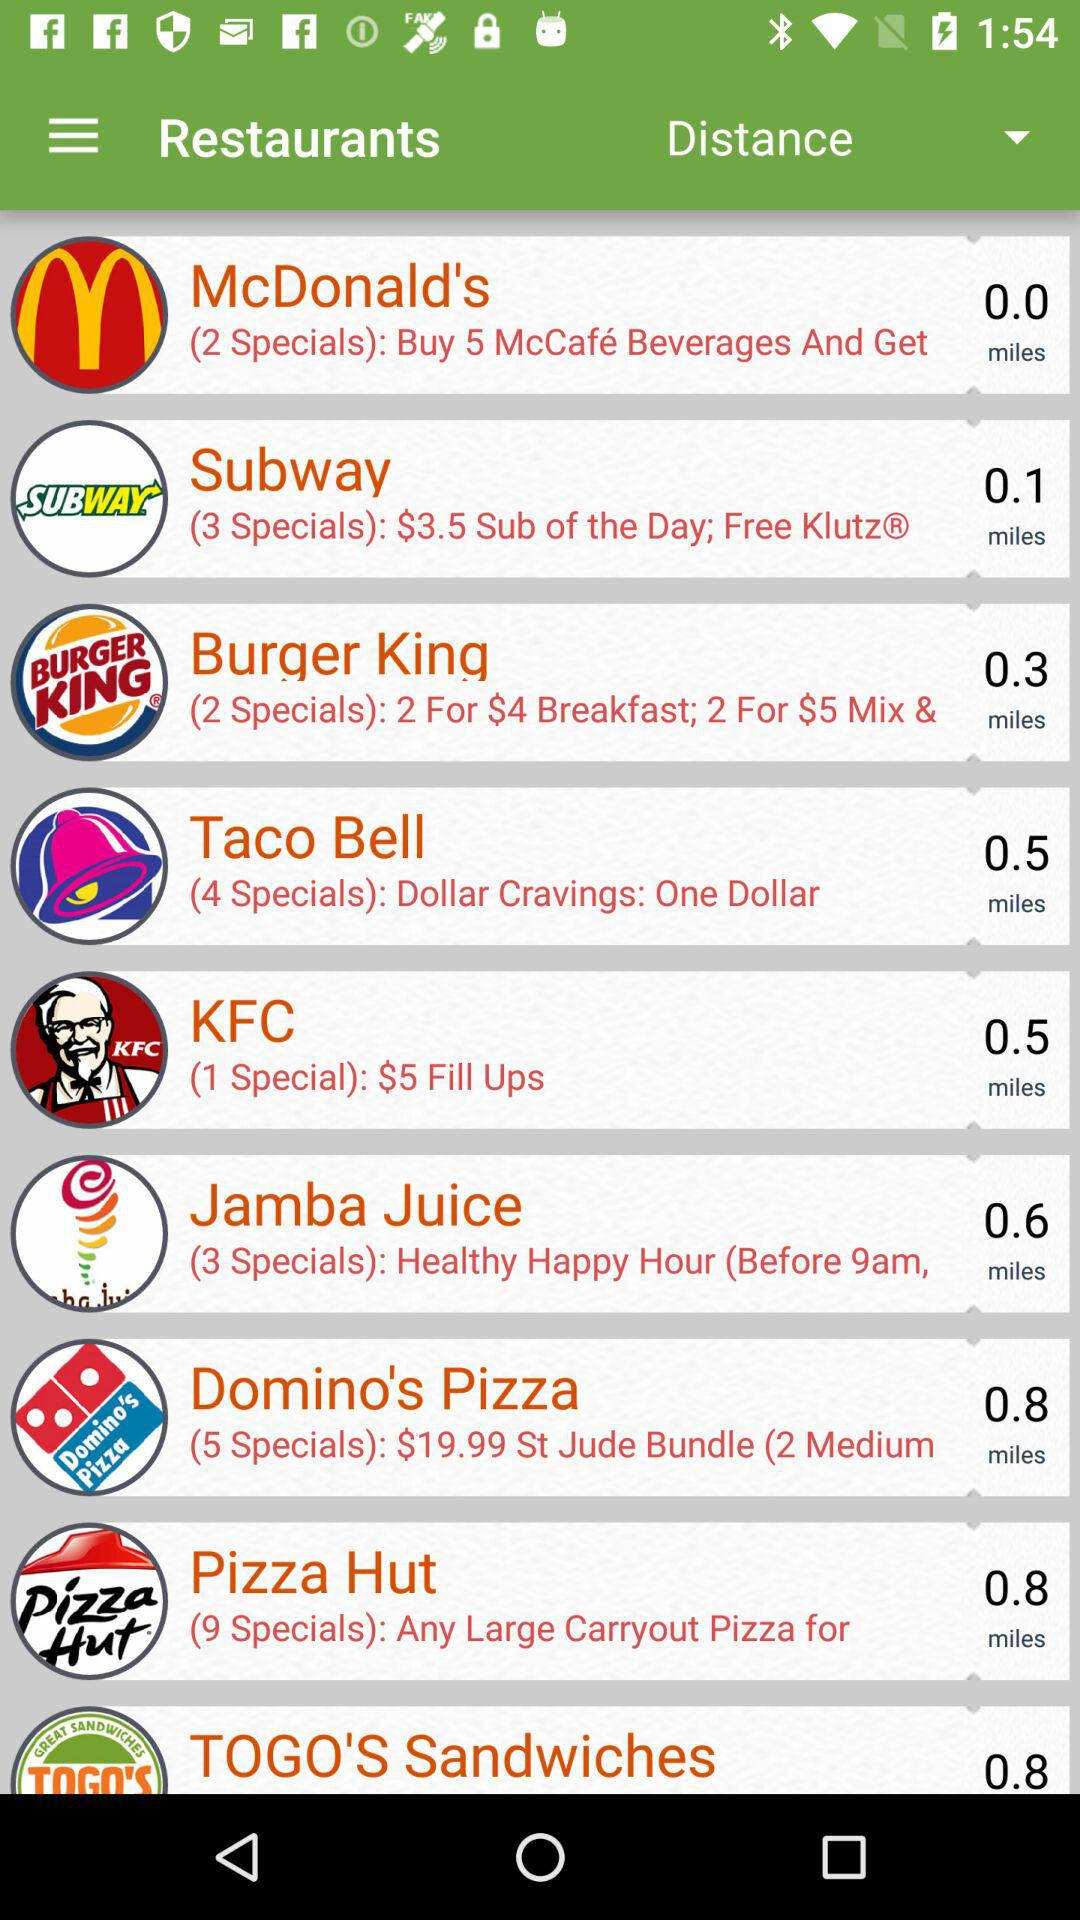What is the distance of KFC in miles? The distance is 0.5 miles. 